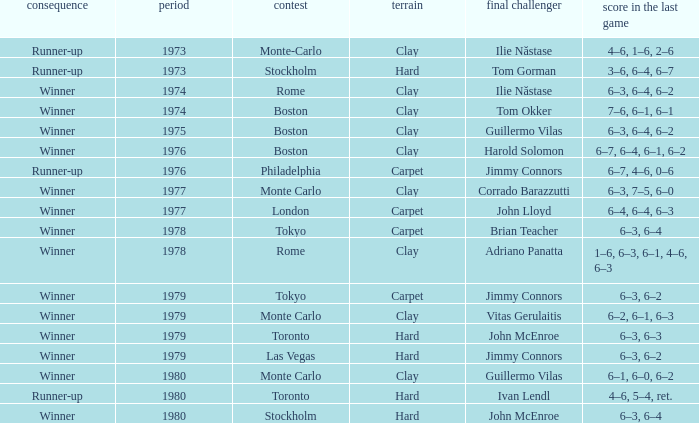Name the championship for clay and corrado barazzutti Monte Carlo. Write the full table. {'header': ['consequence', 'period', 'contest', 'terrain', 'final challenger', 'score in the last game'], 'rows': [['Runner-up', '1973', 'Monte-Carlo', 'Clay', 'Ilie Năstase', '4–6, 1–6, 2–6'], ['Runner-up', '1973', 'Stockholm', 'Hard', 'Tom Gorman', '3–6, 6–4, 6–7'], ['Winner', '1974', 'Rome', 'Clay', 'Ilie Năstase', '6–3, 6–4, 6–2'], ['Winner', '1974', 'Boston', 'Clay', 'Tom Okker', '7–6, 6–1, 6–1'], ['Winner', '1975', 'Boston', 'Clay', 'Guillermo Vilas', '6–3, 6–4, 6–2'], ['Winner', '1976', 'Boston', 'Clay', 'Harold Solomon', '6–7, 6–4, 6–1, 6–2'], ['Runner-up', '1976', 'Philadelphia', 'Carpet', 'Jimmy Connors', '6–7, 4–6, 0–6'], ['Winner', '1977', 'Monte Carlo', 'Clay', 'Corrado Barazzutti', '6–3, 7–5, 6–0'], ['Winner', '1977', 'London', 'Carpet', 'John Lloyd', '6–4, 6–4, 6–3'], ['Winner', '1978', 'Tokyo', 'Carpet', 'Brian Teacher', '6–3, 6–4'], ['Winner', '1978', 'Rome', 'Clay', 'Adriano Panatta', '1–6, 6–3, 6–1, 4–6, 6–3'], ['Winner', '1979', 'Tokyo', 'Carpet', 'Jimmy Connors', '6–3, 6–2'], ['Winner', '1979', 'Monte Carlo', 'Clay', 'Vitas Gerulaitis', '6–2, 6–1, 6–3'], ['Winner', '1979', 'Toronto', 'Hard', 'John McEnroe', '6–3, 6–3'], ['Winner', '1979', 'Las Vegas', 'Hard', 'Jimmy Connors', '6–3, 6–2'], ['Winner', '1980', 'Monte Carlo', 'Clay', 'Guillermo Vilas', '6–1, 6–0, 6–2'], ['Runner-up', '1980', 'Toronto', 'Hard', 'Ivan Lendl', '4–6, 5–4, ret.'], ['Winner', '1980', 'Stockholm', 'Hard', 'John McEnroe', '6–3, 6–4']]} 